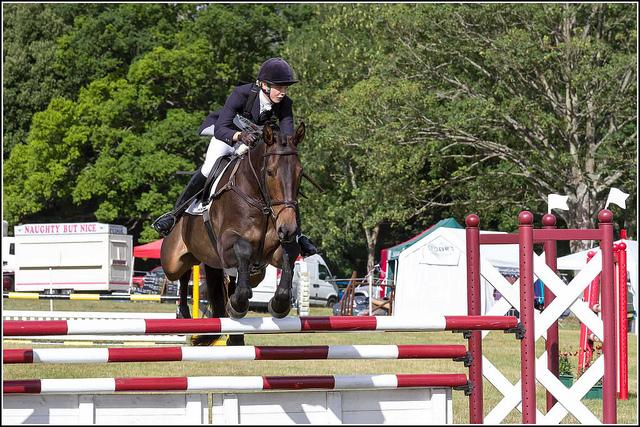What is this sport called? equestrian 